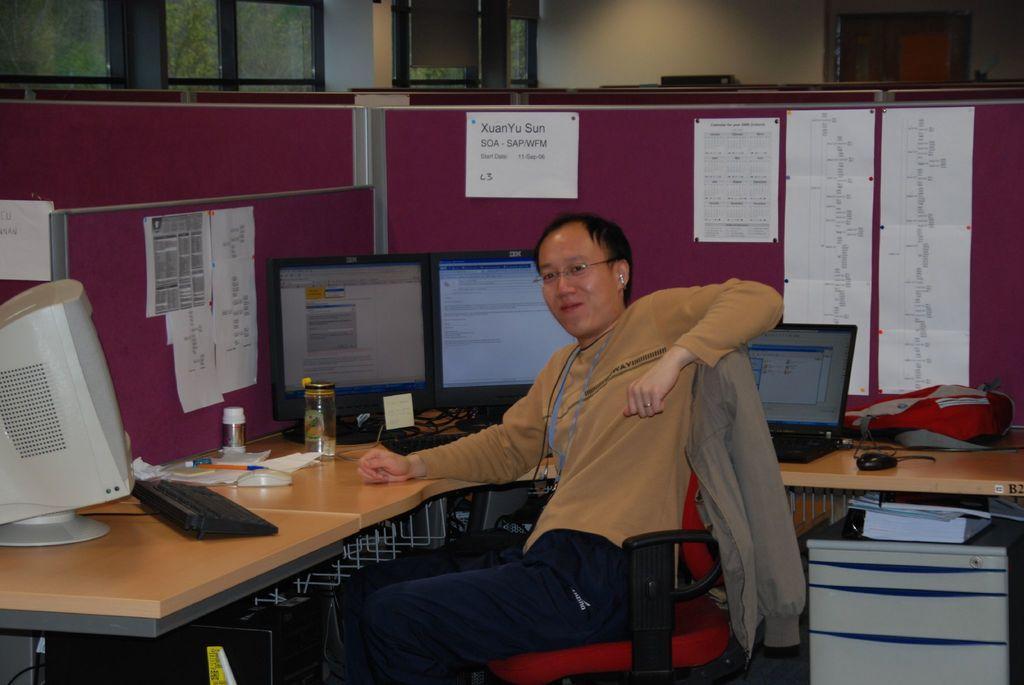Describe this image in one or two sentences. There is a man sitting on a chair and smiling. We can see monitors, laptop, keyboards, mouse, cables, bag, papers, jars and pens on the table, under the table we can see objects on desk. We can see posters and cabins. In the background we can see glass windows and wall. 